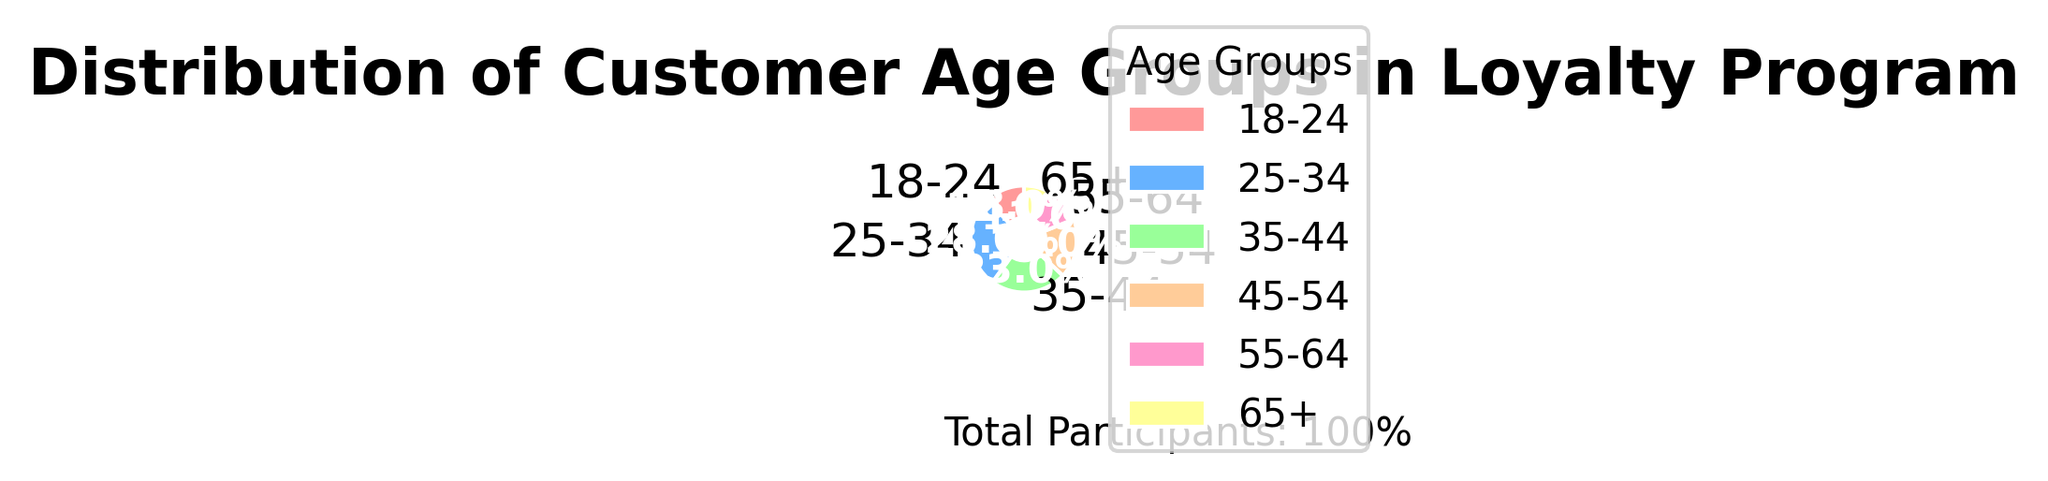What percentage of participants are aged 25-34? Identify the slice labeled ‘25-34’, which is 28% according to the figure.
Answer: 28% Which age group has the smallest percentage of participants? Identify the slice with the smallest percentage, which is labeled ‘65+’ at 8%.
Answer: 65+ Compare the 35-44 and 45-54 age groups; which has more participants and by how much? Refer to the slices labeled '35-44' at 23% and '45-54' at 18%, and calculate the difference: 23% - 18% = 5%.
Answer: 35-44; by 5% What is the combined percentage of participants aged 35-44 and 45-54? Sum the percentages of both age groups: 23% (35-44) + 18% (45-54) = 41%.
Answer: 41% Which two age groups have a combined percentage of exactly 23%? Identify slices that add up to 23%. Here, it is ‘55-64’ at 11% and ‘18-24’ at 12%.
Answer: 18-24 and 55-64 How many more percentage points is the 25-34 age group compared to the 65+ age group? Subtract the percentage of the 65+ age group from the 25-34 age group: 28% - 8% = 20%.
Answer: 20% Which age group has just above half the percentage of participants compared to the 35-44 age group? Identify the groups and their percentages: 35-44 (23%), half of which is 11.5%; the closest higher group is ‘55-64’ at 11%.
Answer: 55-64 What is the most noticeable color on the pie chart? The most noticeable color would be the brightest one, which is often subjective but typically a bright color like red or pink. Here it's likely the slice labeled 18-24 at 12%.
Answer: Color representing 18-24 Compare the total percentage of participants aged below 35 to those aged 35 and above. Which is greater? Sum percentages for ages 18-24 (12%) and 25-34 (28%) for below 35: 12% + 28% = 40%. Sum for ages 35-44 (23%), 45-54 (18%), 55-64 (11%), and 65+ (8%) for 35 and above: 23% + 18% + 11% + 8% = 60%.
Answer: Aged 35 and above 